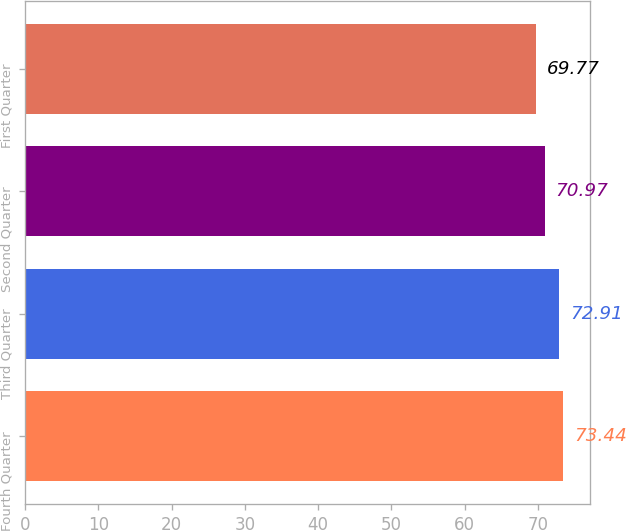Convert chart. <chart><loc_0><loc_0><loc_500><loc_500><bar_chart><fcel>Fourth Quarter<fcel>Third Quarter<fcel>Second Quarter<fcel>First Quarter<nl><fcel>73.44<fcel>72.91<fcel>70.97<fcel>69.77<nl></chart> 